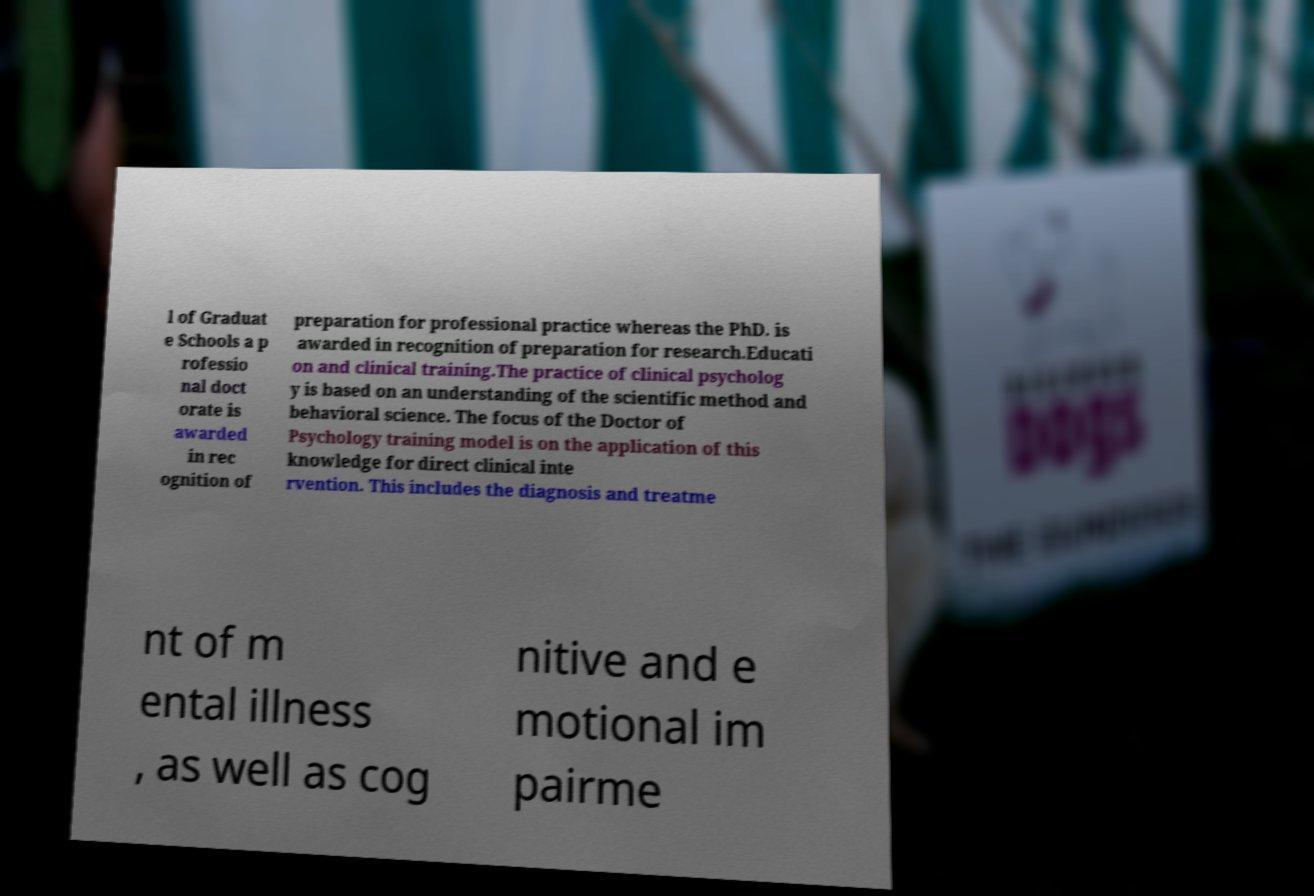What messages or text are displayed in this image? I need them in a readable, typed format. l of Graduat e Schools a p rofessio nal doct orate is awarded in rec ognition of preparation for professional practice whereas the PhD. is awarded in recognition of preparation for research.Educati on and clinical training.The practice of clinical psycholog y is based on an understanding of the scientific method and behavioral science. The focus of the Doctor of Psychology training model is on the application of this knowledge for direct clinical inte rvention. This includes the diagnosis and treatme nt of m ental illness , as well as cog nitive and e motional im pairme 